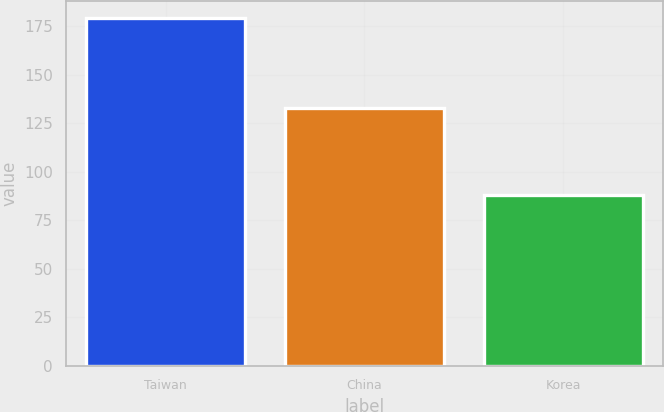Convert chart. <chart><loc_0><loc_0><loc_500><loc_500><bar_chart><fcel>Taiwan<fcel>China<fcel>Korea<nl><fcel>179<fcel>133<fcel>88<nl></chart> 